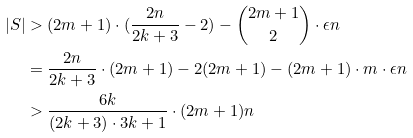<formula> <loc_0><loc_0><loc_500><loc_500>| S | & > ( 2 m + 1 ) \cdot ( \frac { 2 n } { 2 k + 3 } - 2 ) - \binom { 2 m + 1 } { 2 } \cdot \epsilon n \\ & = \frac { 2 n } { 2 k + 3 } \cdot ( 2 m + 1 ) - 2 ( 2 m + 1 ) - ( 2 m + 1 ) \cdot m \cdot \epsilon n \\ & > \frac { 6 k } { ( 2 k + 3 ) \cdot 3 k + 1 } \cdot ( 2 m + 1 ) n</formula> 